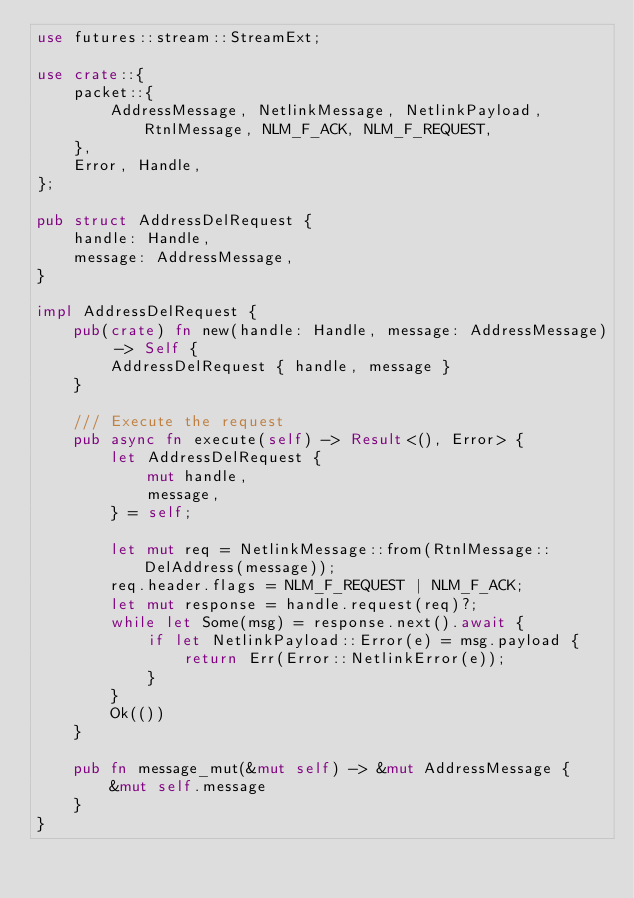Convert code to text. <code><loc_0><loc_0><loc_500><loc_500><_Rust_>use futures::stream::StreamExt;

use crate::{
    packet::{
        AddressMessage, NetlinkMessage, NetlinkPayload, RtnlMessage, NLM_F_ACK, NLM_F_REQUEST,
    },
    Error, Handle,
};

pub struct AddressDelRequest {
    handle: Handle,
    message: AddressMessage,
}

impl AddressDelRequest {
    pub(crate) fn new(handle: Handle, message: AddressMessage) -> Self {
        AddressDelRequest { handle, message }
    }

    /// Execute the request
    pub async fn execute(self) -> Result<(), Error> {
        let AddressDelRequest {
            mut handle,
            message,
        } = self;

        let mut req = NetlinkMessage::from(RtnlMessage::DelAddress(message));
        req.header.flags = NLM_F_REQUEST | NLM_F_ACK;
        let mut response = handle.request(req)?;
        while let Some(msg) = response.next().await {
            if let NetlinkPayload::Error(e) = msg.payload {
                return Err(Error::NetlinkError(e));
            }
        }
        Ok(())
    }

    pub fn message_mut(&mut self) -> &mut AddressMessage {
        &mut self.message
    }
}
</code> 